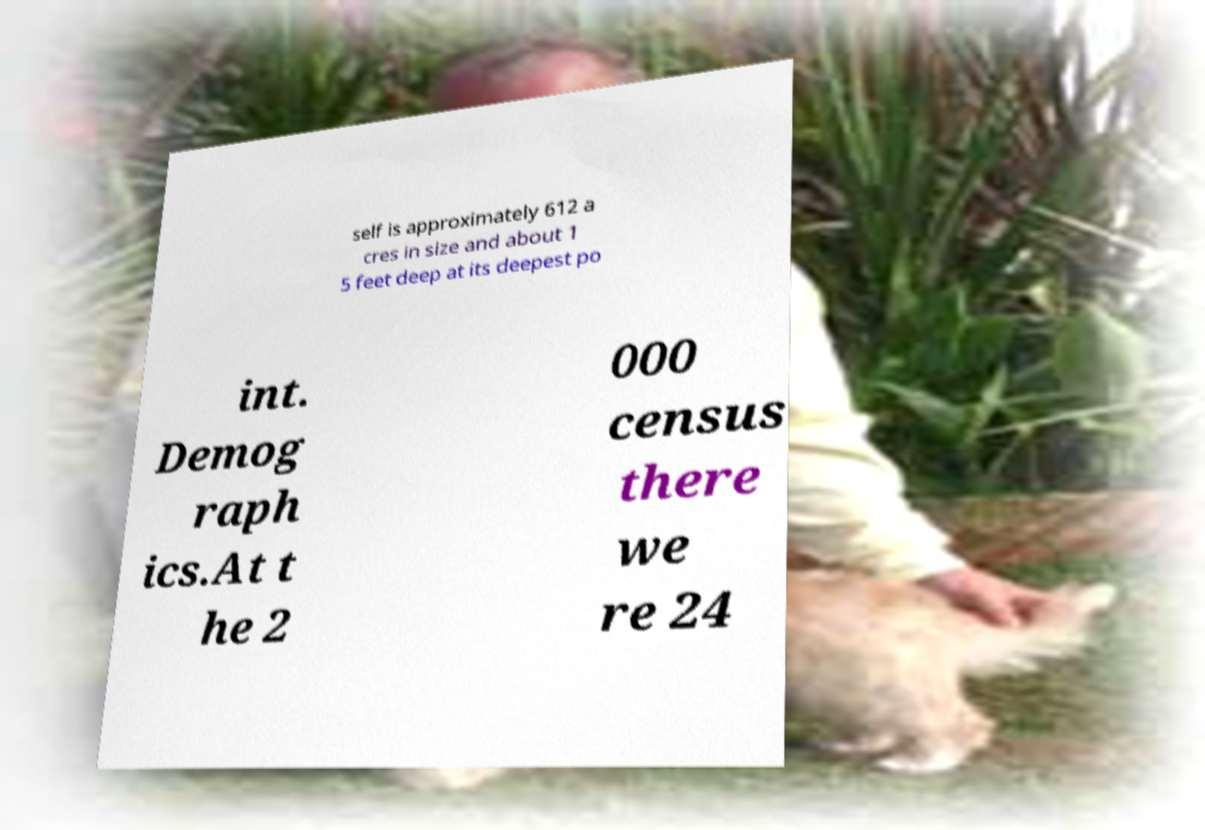Could you extract and type out the text from this image? self is approximately 612 a cres in size and about 1 5 feet deep at its deepest po int. Demog raph ics.At t he 2 000 census there we re 24 